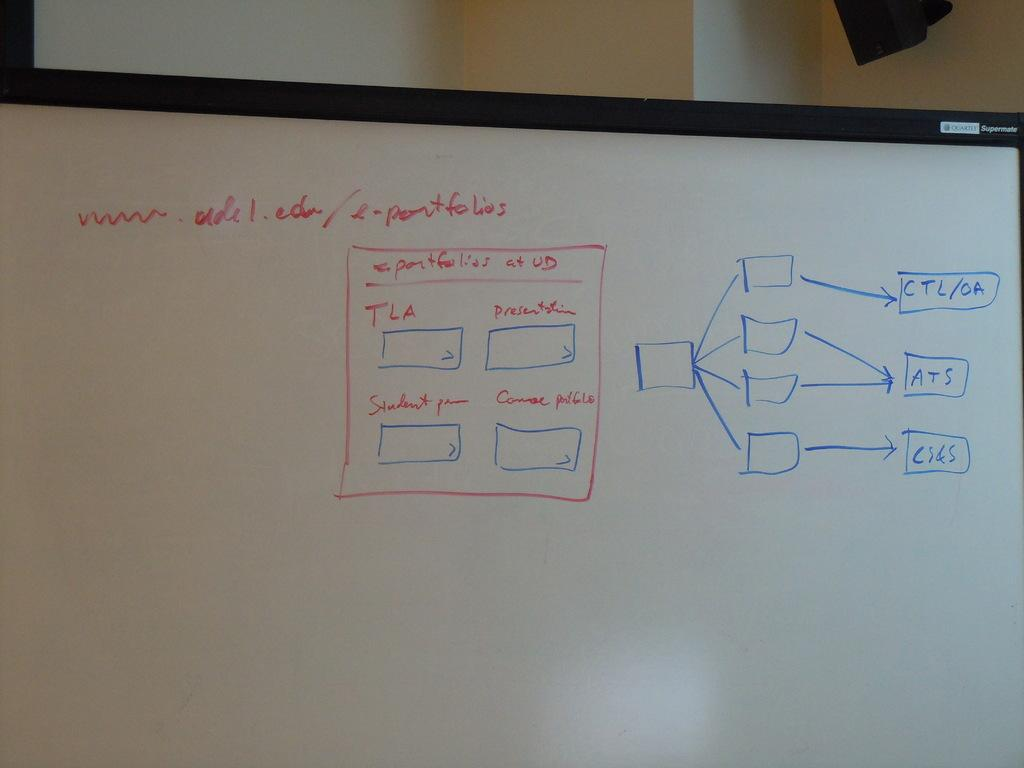<image>
Relay a brief, clear account of the picture shown. A diagram on a whiteboard drawn in red and blue ink about presentations and course portfolios. 